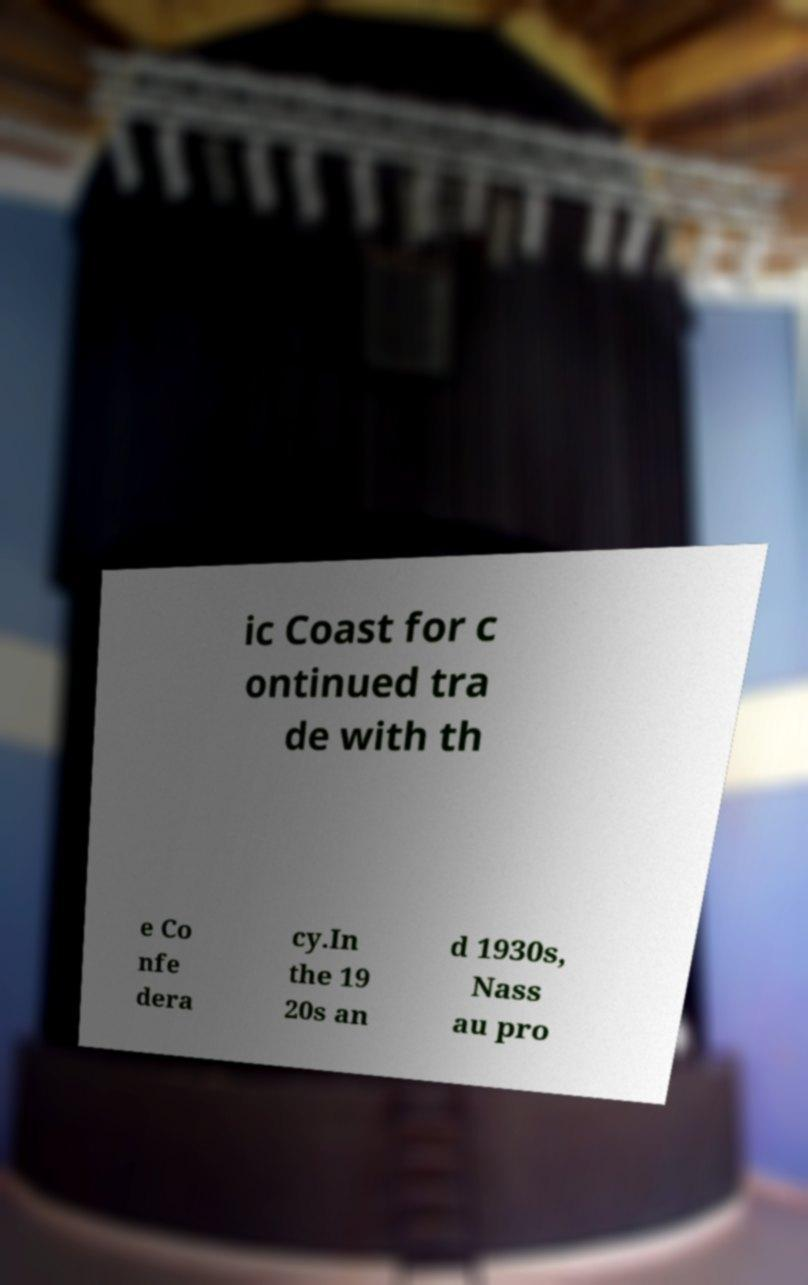For documentation purposes, I need the text within this image transcribed. Could you provide that? ic Coast for c ontinued tra de with th e Co nfe dera cy.In the 19 20s an d 1930s, Nass au pro 